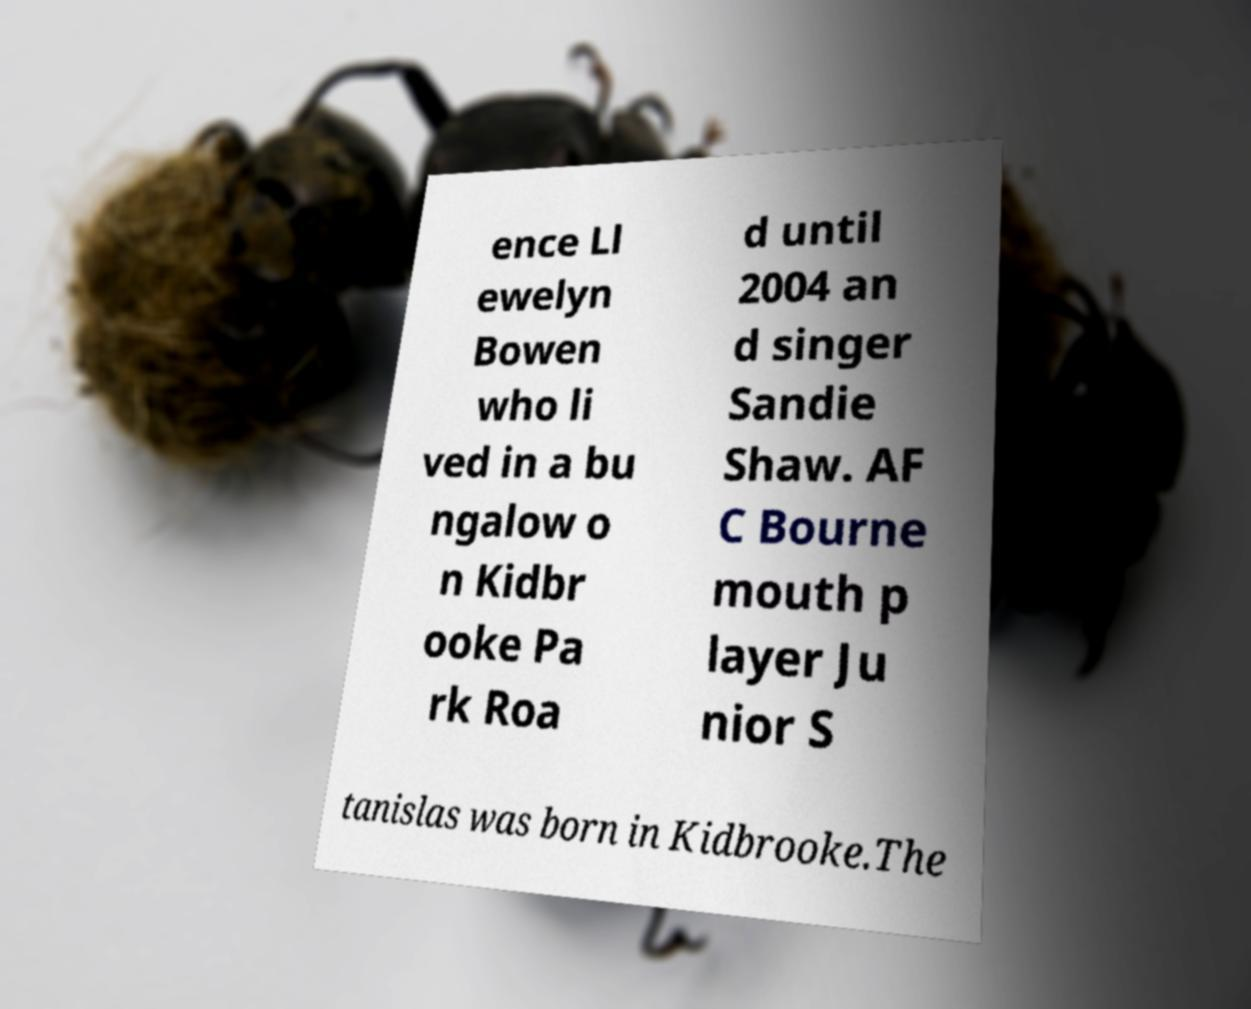Can you accurately transcribe the text from the provided image for me? ence Ll ewelyn Bowen who li ved in a bu ngalow o n Kidbr ooke Pa rk Roa d until 2004 an d singer Sandie Shaw. AF C Bourne mouth p layer Ju nior S tanislas was born in Kidbrooke.The 